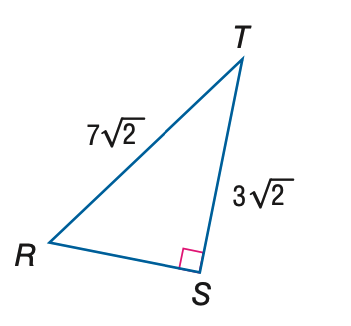Answer the mathemtical geometry problem and directly provide the correct option letter.
Question: Find the measure of \angle T to the nearest tenth.
Choices: A: 23.2 B: 25.4 C: 64.6 D: 66.8 C 